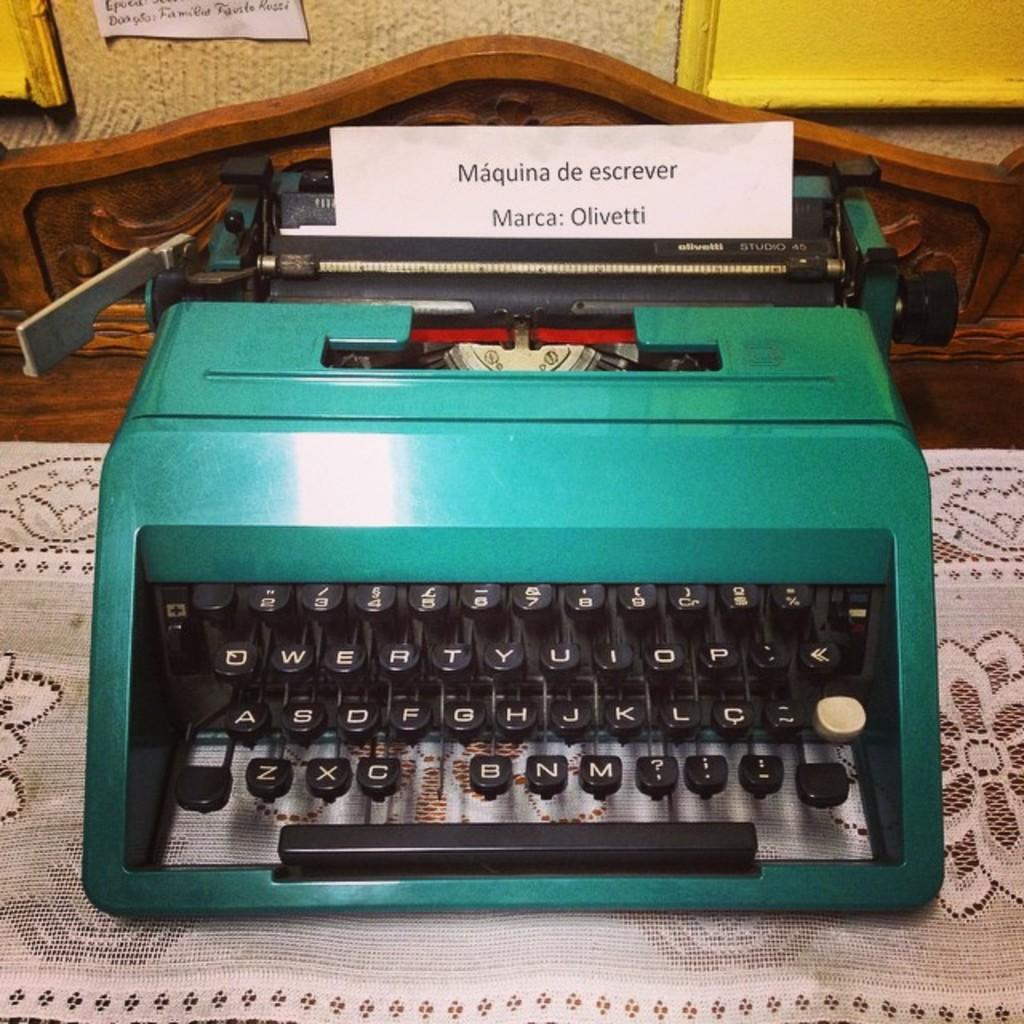Is there a "c" key?
Give a very brief answer. Yes. What name comes after marca?
Your response must be concise. Olivetti. 